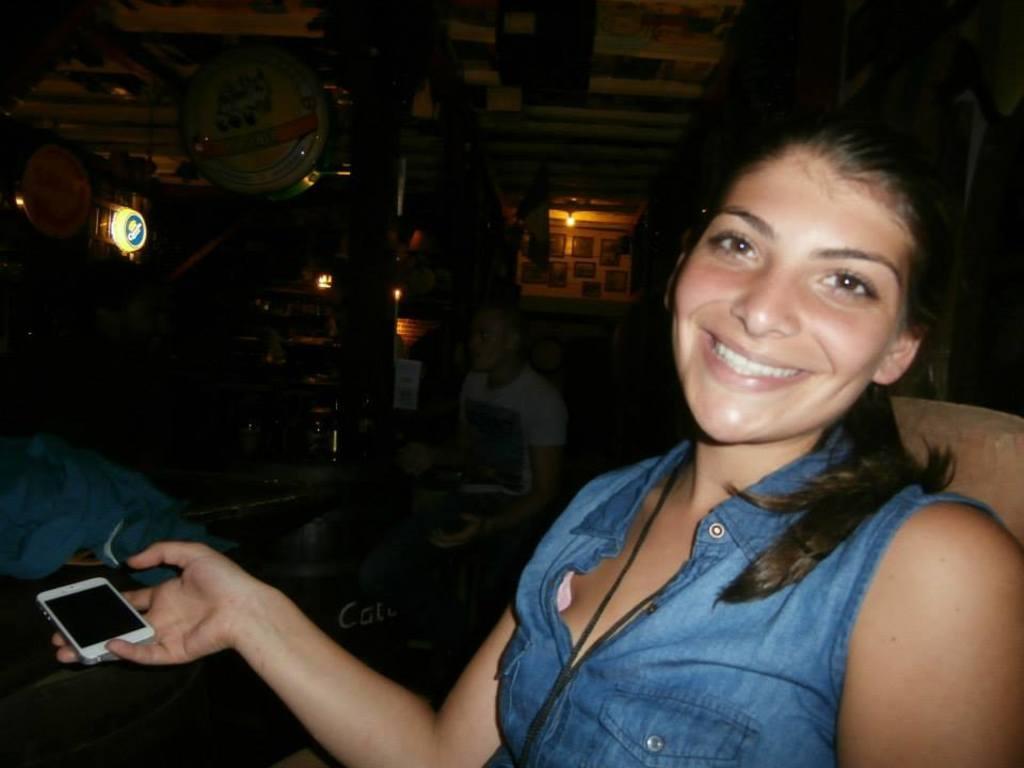Could you give a brief overview of what you see in this image? In the picture there is a woman sitting on a chair. She is wearing a blue dress with tag and she is holding a mobile phone. In the background we can see a person sitting on the chair near the table, on the table we can see some items, and in the background we can see a lights, and a decorated wall. 